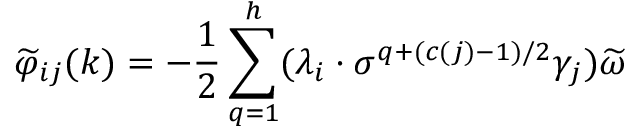Convert formula to latex. <formula><loc_0><loc_0><loc_500><loc_500>\widetilde { \varphi } _ { i j } ( k ) = - \frac { 1 } { 2 } \sum _ { q = 1 } ^ { h } ( \lambda _ { i } \cdot \sigma ^ { q + ( c ( j ) - 1 ) / 2 } \gamma _ { j } ) \widetilde { \omega }</formula> 